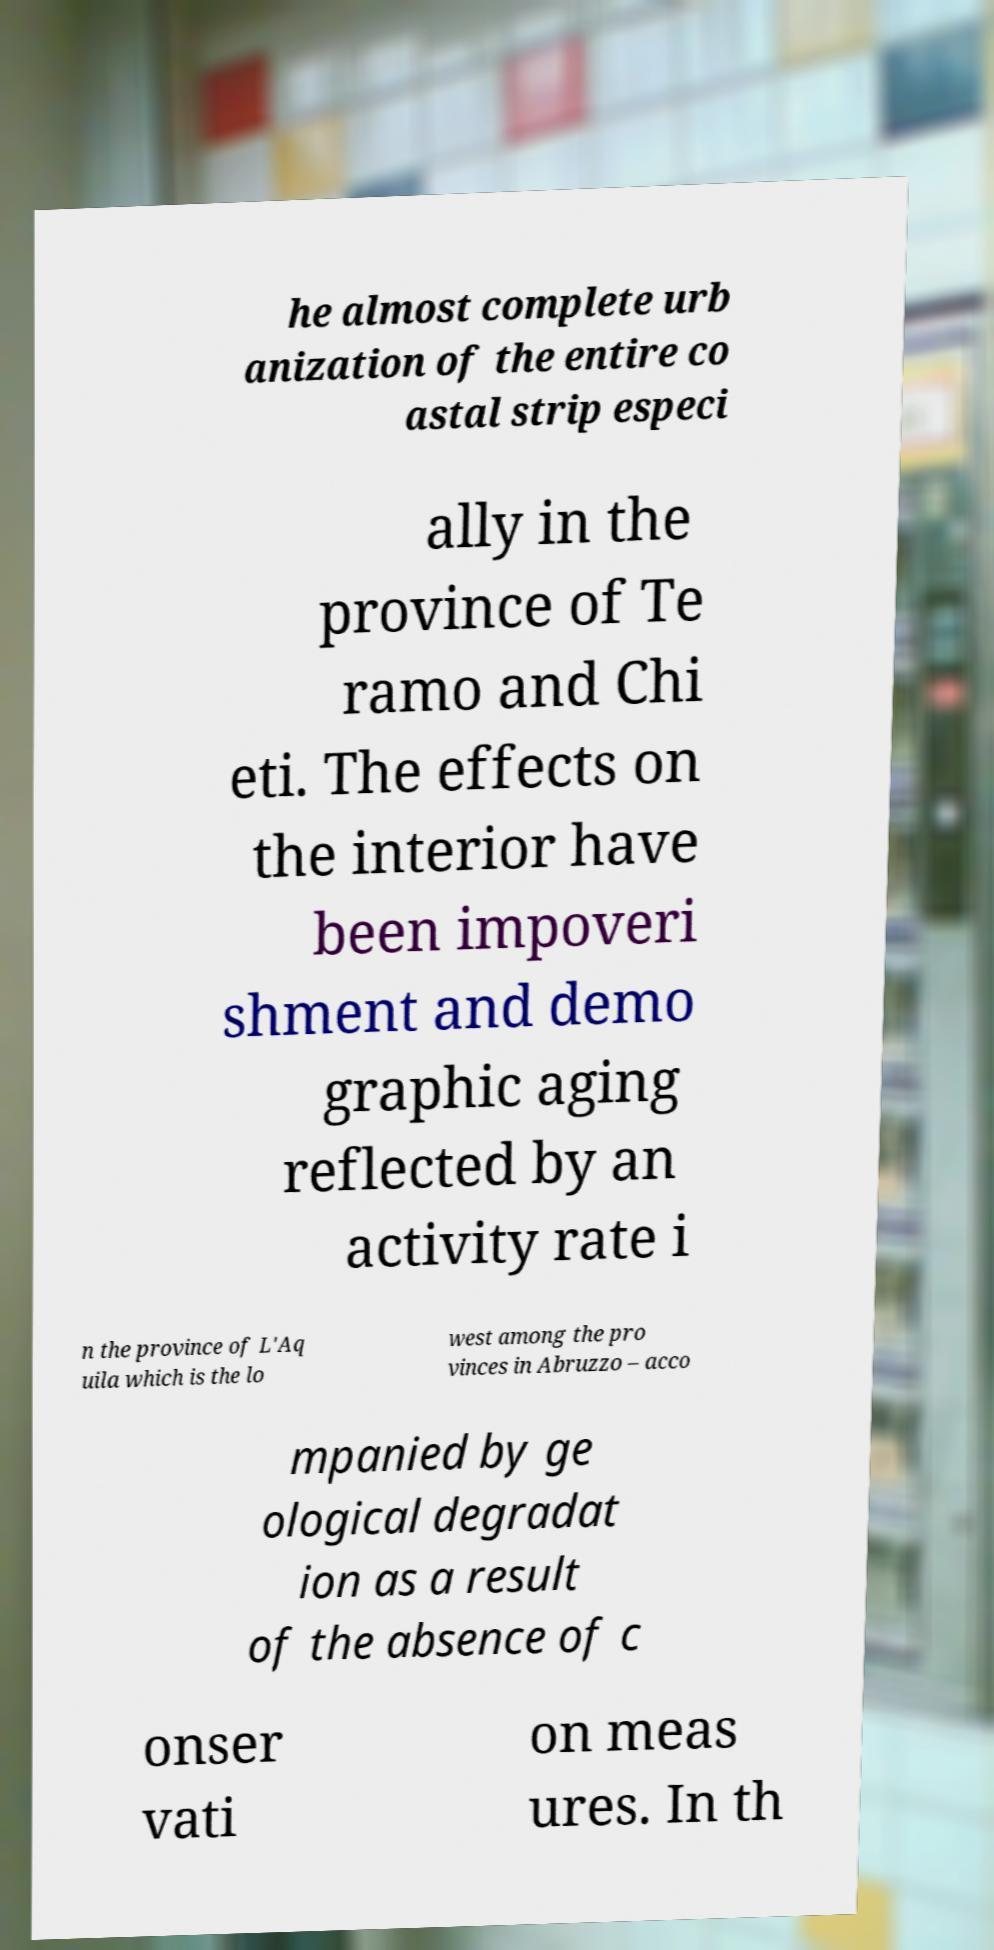Please read and relay the text visible in this image. What does it say? he almost complete urb anization of the entire co astal strip especi ally in the province of Te ramo and Chi eti. The effects on the interior have been impoveri shment and demo graphic aging reflected by an activity rate i n the province of L'Aq uila which is the lo west among the pro vinces in Abruzzo – acco mpanied by ge ological degradat ion as a result of the absence of c onser vati on meas ures. In th 